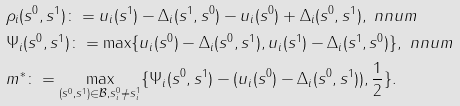Convert formula to latex. <formula><loc_0><loc_0><loc_500><loc_500>& \rho _ { i } ( s ^ { 0 } , s ^ { 1 } ) \colon = u _ { i } ( s ^ { 1 } ) - \Delta _ { i } ( s ^ { 1 } , s ^ { 0 } ) - u _ { i } ( s ^ { 0 } ) + \Delta _ { i } ( s ^ { 0 } , s ^ { 1 } ) , \ n n u m \\ & \Psi _ { i } ( s ^ { 0 } , s ^ { 1 } ) \colon = \max \{ u _ { i } ( s ^ { 0 } ) - \Delta _ { i } ( s ^ { 0 } , s ^ { 1 } ) , u _ { i } ( s ^ { 1 } ) - \Delta _ { i } ( s ^ { 1 } , s ^ { 0 } ) \} , \ n n u m \\ & m ^ { * } \colon = \max _ { ( s ^ { 0 } , s ^ { 1 } ) \in { \mathcal { B } } , s _ { i } ^ { 0 } \neq s _ { i } ^ { 1 } } \{ \Psi _ { i } ( s ^ { 0 } , s ^ { 1 } ) - ( u _ { i } ( s ^ { 0 } ) - \Delta _ { i } ( s ^ { 0 } , s ^ { 1 } ) ) , \frac { 1 } { 2 } \} .</formula> 